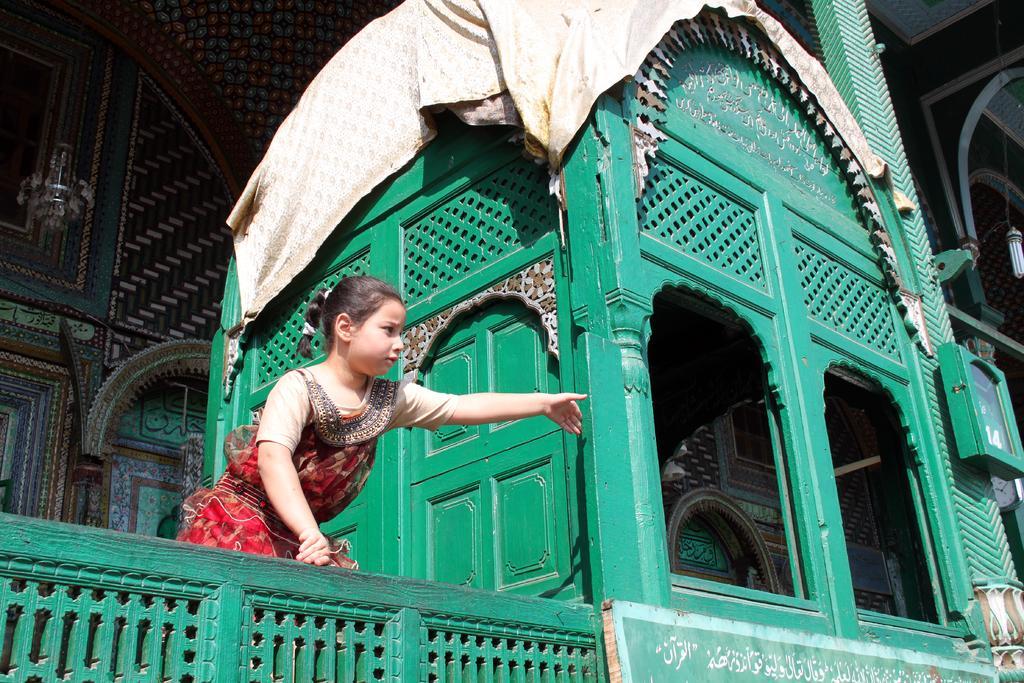Please provide a concise description of this image. In this image there is a building and we can see a girl. There are clothes. On the right there is a light. 